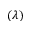Convert formula to latex. <formula><loc_0><loc_0><loc_500><loc_500>( \lambda )</formula> 